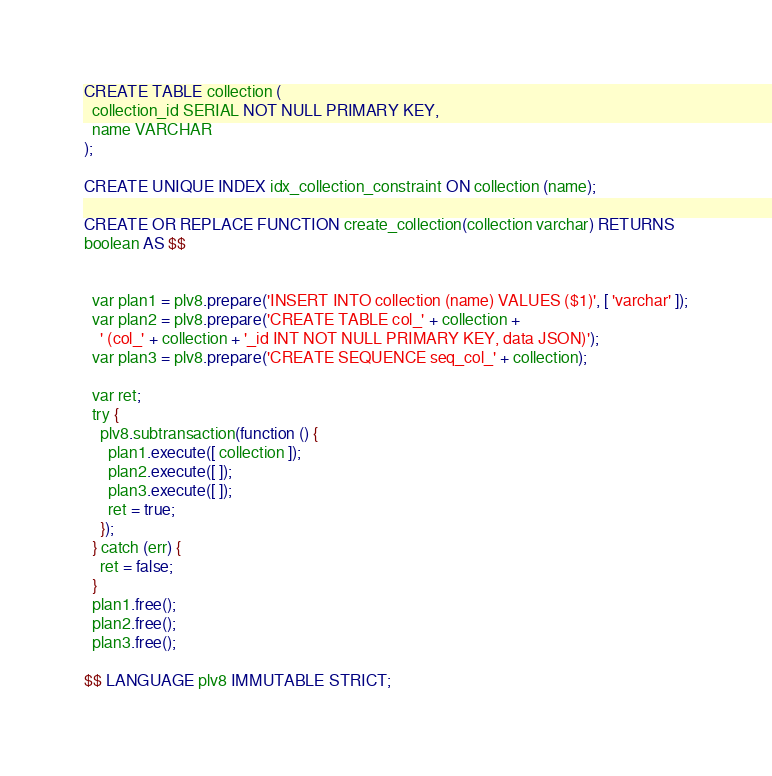<code> <loc_0><loc_0><loc_500><loc_500><_SQL_>CREATE TABLE collection (
  collection_id SERIAL NOT NULL PRIMARY KEY,
  name VARCHAR
);

CREATE UNIQUE INDEX idx_collection_constraint ON collection (name);

CREATE OR REPLACE FUNCTION create_collection(collection varchar) RETURNS
boolean AS $$


  var plan1 = plv8.prepare('INSERT INTO collection (name) VALUES ($1)', [ 'varchar' ]);
  var plan2 = plv8.prepare('CREATE TABLE col_' + collection +
    ' (col_' + collection + '_id INT NOT NULL PRIMARY KEY, data JSON)');
  var plan3 = plv8.prepare('CREATE SEQUENCE seq_col_' + collection);

  var ret;
  try {
    plv8.subtransaction(function () {
      plan1.execute([ collection ]);
      plan2.execute([ ]);
      plan3.execute([ ]);
      ret = true;
    });
  } catch (err) {
    ret = false;
  }
  plan1.free();
  plan2.free();
  plan3.free();

$$ LANGUAGE plv8 IMMUTABLE STRICT;
</code> 